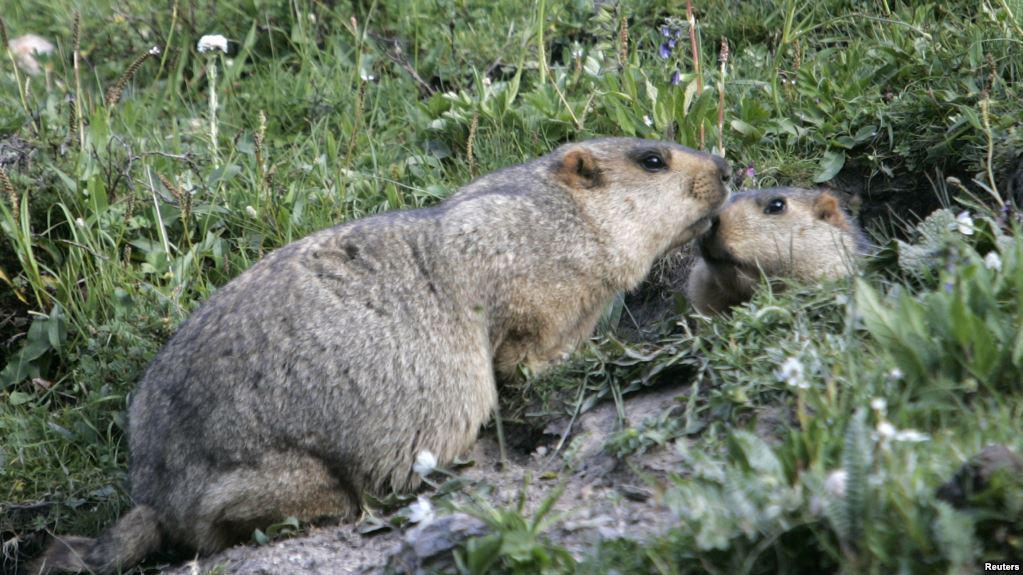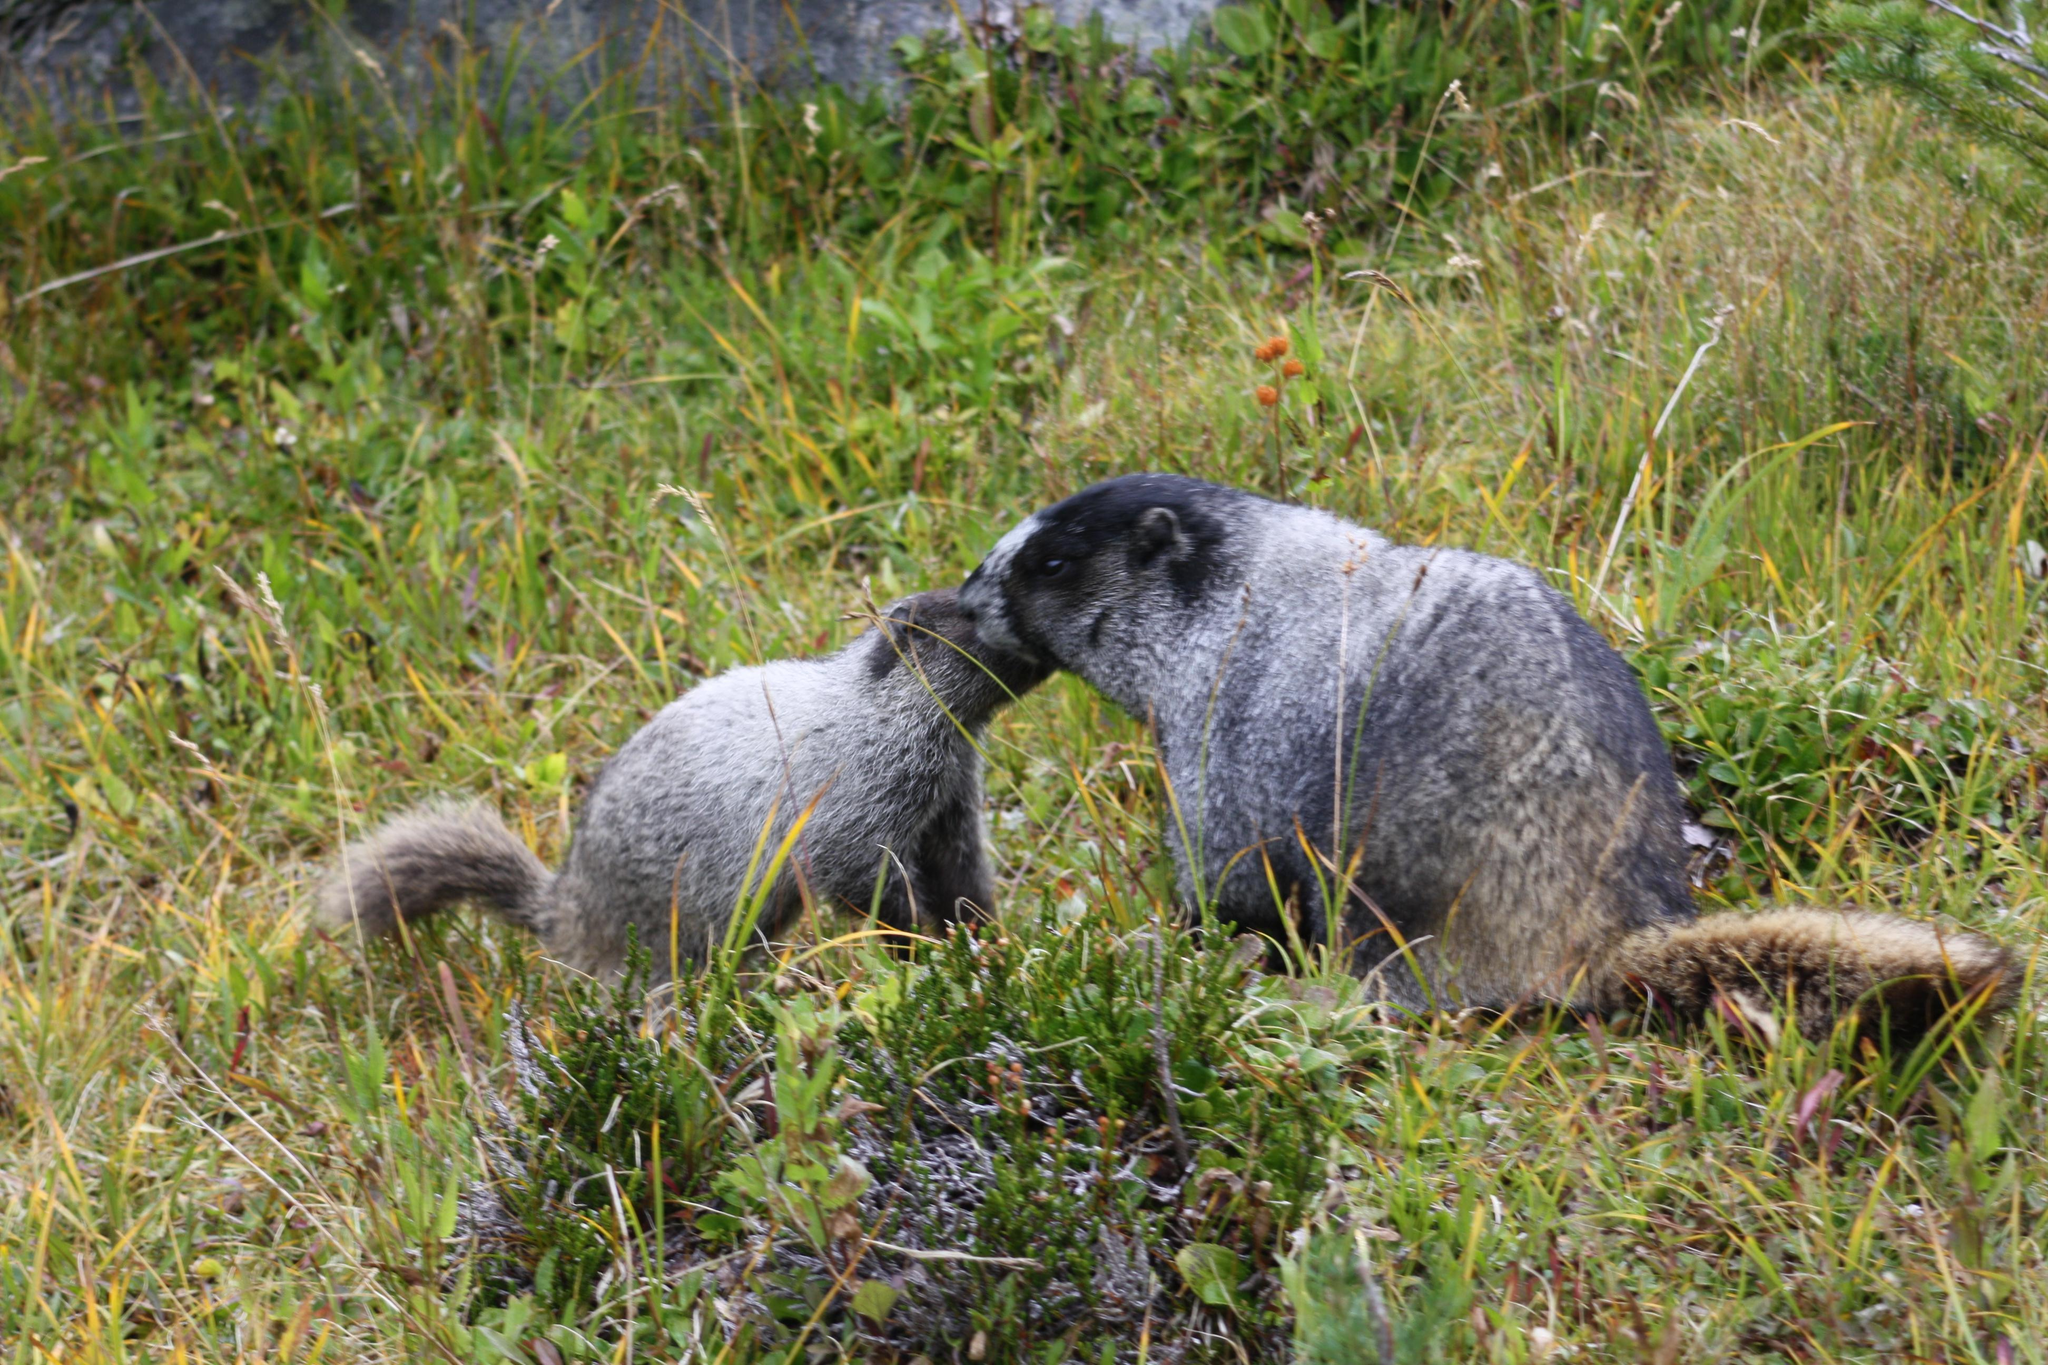The first image is the image on the left, the second image is the image on the right. Given the left and right images, does the statement "Right image shows two marmots on all fours posed face-to-face." hold true? Answer yes or no. Yes. The first image is the image on the left, the second image is the image on the right. Analyze the images presented: Is the assertion "Two animals are interacting in a field in both images." valid? Answer yes or no. Yes. 